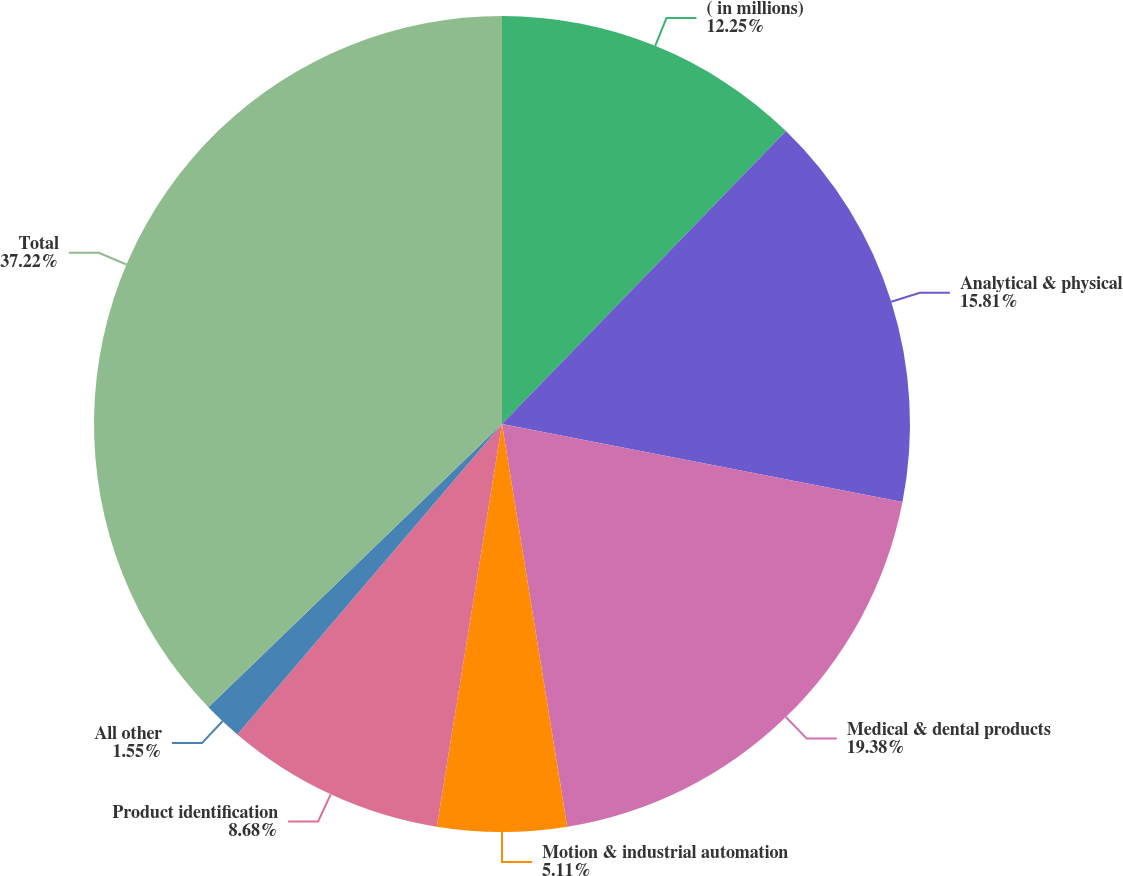<chart> <loc_0><loc_0><loc_500><loc_500><pie_chart><fcel>( in millions)<fcel>Analytical & physical<fcel>Medical & dental products<fcel>Motion & industrial automation<fcel>Product identification<fcel>All other<fcel>Total<nl><fcel>12.25%<fcel>15.81%<fcel>19.38%<fcel>5.11%<fcel>8.68%<fcel>1.55%<fcel>37.21%<nl></chart> 